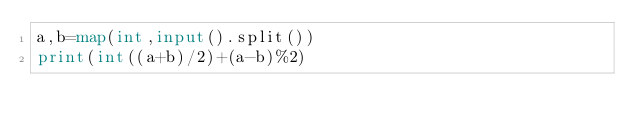Convert code to text. <code><loc_0><loc_0><loc_500><loc_500><_Python_>a,b=map(int,input().split())
print(int((a+b)/2)+(a-b)%2)</code> 